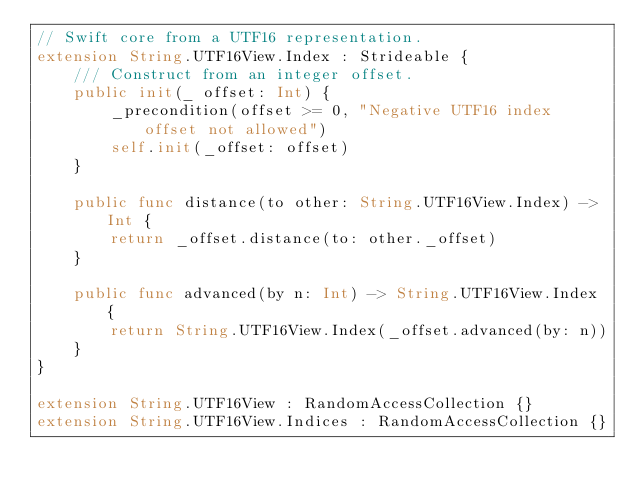Convert code to text. <code><loc_0><loc_0><loc_500><loc_500><_Swift_>// Swift core from a UTF16 representation.
extension String.UTF16View.Index : Strideable {
    /// Construct from an integer offset.
    public init(_ offset: Int) {
        _precondition(offset >= 0, "Negative UTF16 index offset not allowed")
        self.init(_offset: offset)
    }
    
    public func distance(to other: String.UTF16View.Index) -> Int {
        return _offset.distance(to: other._offset)
    }
    
    public func advanced(by n: Int) -> String.UTF16View.Index {
        return String.UTF16View.Index(_offset.advanced(by: n))
    }
}

extension String.UTF16View : RandomAccessCollection {}
extension String.UTF16View.Indices : RandomAccessCollection {}

</code> 